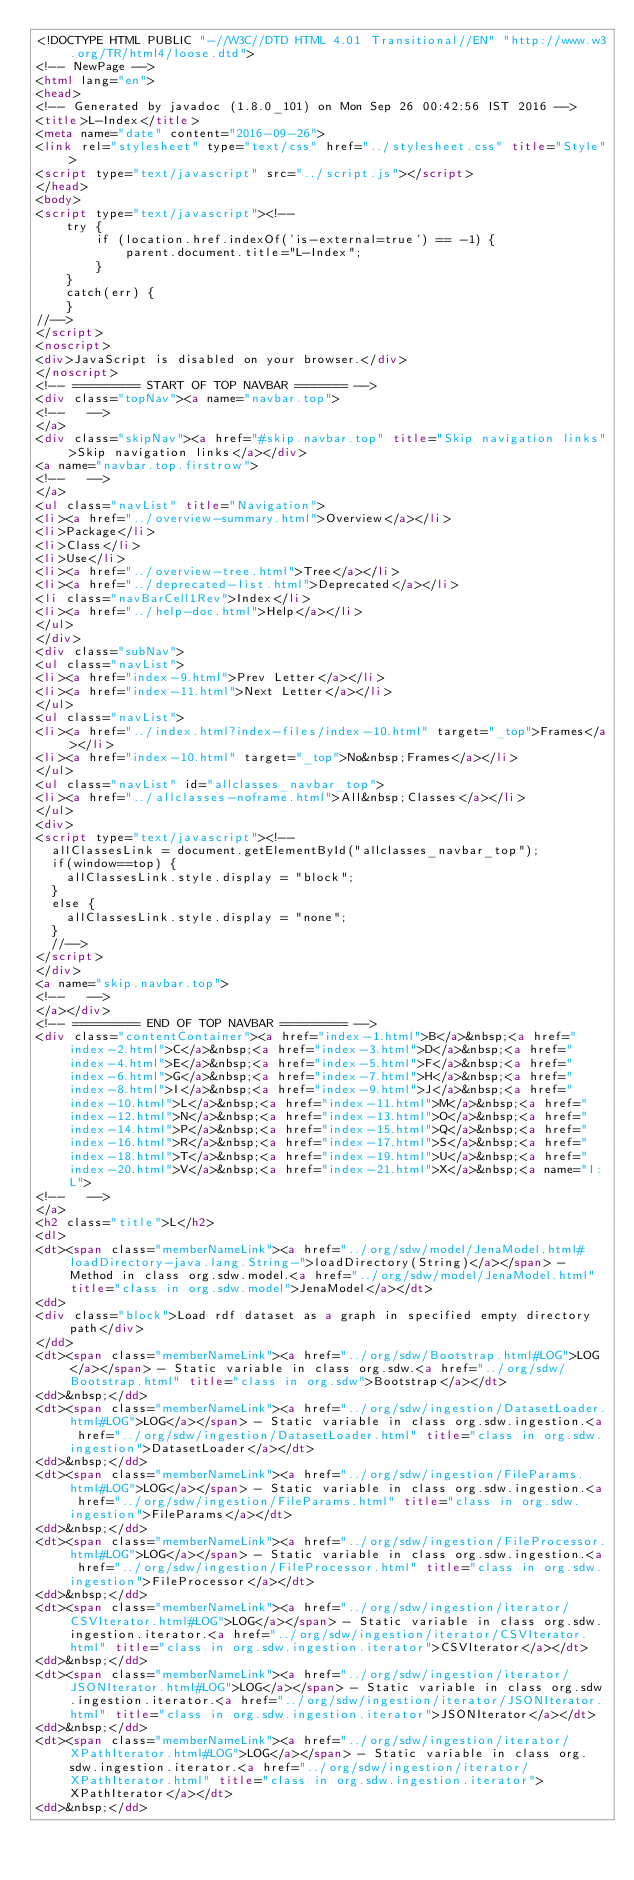<code> <loc_0><loc_0><loc_500><loc_500><_HTML_><!DOCTYPE HTML PUBLIC "-//W3C//DTD HTML 4.01 Transitional//EN" "http://www.w3.org/TR/html4/loose.dtd">
<!-- NewPage -->
<html lang="en">
<head>
<!-- Generated by javadoc (1.8.0_101) on Mon Sep 26 00:42:56 IST 2016 -->
<title>L-Index</title>
<meta name="date" content="2016-09-26">
<link rel="stylesheet" type="text/css" href="../stylesheet.css" title="Style">
<script type="text/javascript" src="../script.js"></script>
</head>
<body>
<script type="text/javascript"><!--
    try {
        if (location.href.indexOf('is-external=true') == -1) {
            parent.document.title="L-Index";
        }
    }
    catch(err) {
    }
//-->
</script>
<noscript>
<div>JavaScript is disabled on your browser.</div>
</noscript>
<!-- ========= START OF TOP NAVBAR ======= -->
<div class="topNav"><a name="navbar.top">
<!--   -->
</a>
<div class="skipNav"><a href="#skip.navbar.top" title="Skip navigation links">Skip navigation links</a></div>
<a name="navbar.top.firstrow">
<!--   -->
</a>
<ul class="navList" title="Navigation">
<li><a href="../overview-summary.html">Overview</a></li>
<li>Package</li>
<li>Class</li>
<li>Use</li>
<li><a href="../overview-tree.html">Tree</a></li>
<li><a href="../deprecated-list.html">Deprecated</a></li>
<li class="navBarCell1Rev">Index</li>
<li><a href="../help-doc.html">Help</a></li>
</ul>
</div>
<div class="subNav">
<ul class="navList">
<li><a href="index-9.html">Prev Letter</a></li>
<li><a href="index-11.html">Next Letter</a></li>
</ul>
<ul class="navList">
<li><a href="../index.html?index-files/index-10.html" target="_top">Frames</a></li>
<li><a href="index-10.html" target="_top">No&nbsp;Frames</a></li>
</ul>
<ul class="navList" id="allclasses_navbar_top">
<li><a href="../allclasses-noframe.html">All&nbsp;Classes</a></li>
</ul>
<div>
<script type="text/javascript"><!--
  allClassesLink = document.getElementById("allclasses_navbar_top");
  if(window==top) {
    allClassesLink.style.display = "block";
  }
  else {
    allClassesLink.style.display = "none";
  }
  //-->
</script>
</div>
<a name="skip.navbar.top">
<!--   -->
</a></div>
<!-- ========= END OF TOP NAVBAR ========= -->
<div class="contentContainer"><a href="index-1.html">B</a>&nbsp;<a href="index-2.html">C</a>&nbsp;<a href="index-3.html">D</a>&nbsp;<a href="index-4.html">E</a>&nbsp;<a href="index-5.html">F</a>&nbsp;<a href="index-6.html">G</a>&nbsp;<a href="index-7.html">H</a>&nbsp;<a href="index-8.html">I</a>&nbsp;<a href="index-9.html">J</a>&nbsp;<a href="index-10.html">L</a>&nbsp;<a href="index-11.html">M</a>&nbsp;<a href="index-12.html">N</a>&nbsp;<a href="index-13.html">O</a>&nbsp;<a href="index-14.html">P</a>&nbsp;<a href="index-15.html">Q</a>&nbsp;<a href="index-16.html">R</a>&nbsp;<a href="index-17.html">S</a>&nbsp;<a href="index-18.html">T</a>&nbsp;<a href="index-19.html">U</a>&nbsp;<a href="index-20.html">V</a>&nbsp;<a href="index-21.html">X</a>&nbsp;<a name="I:L">
<!--   -->
</a>
<h2 class="title">L</h2>
<dl>
<dt><span class="memberNameLink"><a href="../org/sdw/model/JenaModel.html#loadDirectory-java.lang.String-">loadDirectory(String)</a></span> - Method in class org.sdw.model.<a href="../org/sdw/model/JenaModel.html" title="class in org.sdw.model">JenaModel</a></dt>
<dd>
<div class="block">Load rdf dataset as a graph in specified empty directory path</div>
</dd>
<dt><span class="memberNameLink"><a href="../org/sdw/Bootstrap.html#LOG">LOG</a></span> - Static variable in class org.sdw.<a href="../org/sdw/Bootstrap.html" title="class in org.sdw">Bootstrap</a></dt>
<dd>&nbsp;</dd>
<dt><span class="memberNameLink"><a href="../org/sdw/ingestion/DatasetLoader.html#LOG">LOG</a></span> - Static variable in class org.sdw.ingestion.<a href="../org/sdw/ingestion/DatasetLoader.html" title="class in org.sdw.ingestion">DatasetLoader</a></dt>
<dd>&nbsp;</dd>
<dt><span class="memberNameLink"><a href="../org/sdw/ingestion/FileParams.html#LOG">LOG</a></span> - Static variable in class org.sdw.ingestion.<a href="../org/sdw/ingestion/FileParams.html" title="class in org.sdw.ingestion">FileParams</a></dt>
<dd>&nbsp;</dd>
<dt><span class="memberNameLink"><a href="../org/sdw/ingestion/FileProcessor.html#LOG">LOG</a></span> - Static variable in class org.sdw.ingestion.<a href="../org/sdw/ingestion/FileProcessor.html" title="class in org.sdw.ingestion">FileProcessor</a></dt>
<dd>&nbsp;</dd>
<dt><span class="memberNameLink"><a href="../org/sdw/ingestion/iterator/CSVIterator.html#LOG">LOG</a></span> - Static variable in class org.sdw.ingestion.iterator.<a href="../org/sdw/ingestion/iterator/CSVIterator.html" title="class in org.sdw.ingestion.iterator">CSVIterator</a></dt>
<dd>&nbsp;</dd>
<dt><span class="memberNameLink"><a href="../org/sdw/ingestion/iterator/JSONIterator.html#LOG">LOG</a></span> - Static variable in class org.sdw.ingestion.iterator.<a href="../org/sdw/ingestion/iterator/JSONIterator.html" title="class in org.sdw.ingestion.iterator">JSONIterator</a></dt>
<dd>&nbsp;</dd>
<dt><span class="memberNameLink"><a href="../org/sdw/ingestion/iterator/XPathIterator.html#LOG">LOG</a></span> - Static variable in class org.sdw.ingestion.iterator.<a href="../org/sdw/ingestion/iterator/XPathIterator.html" title="class in org.sdw.ingestion.iterator">XPathIterator</a></dt>
<dd>&nbsp;</dd></code> 